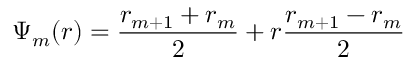Convert formula to latex. <formula><loc_0><loc_0><loc_500><loc_500>\Psi _ { m } ( r ) = \frac { r _ { m + 1 } + r _ { m } } { 2 } + r \frac { r _ { m + 1 } - r _ { m } } { 2 }</formula> 